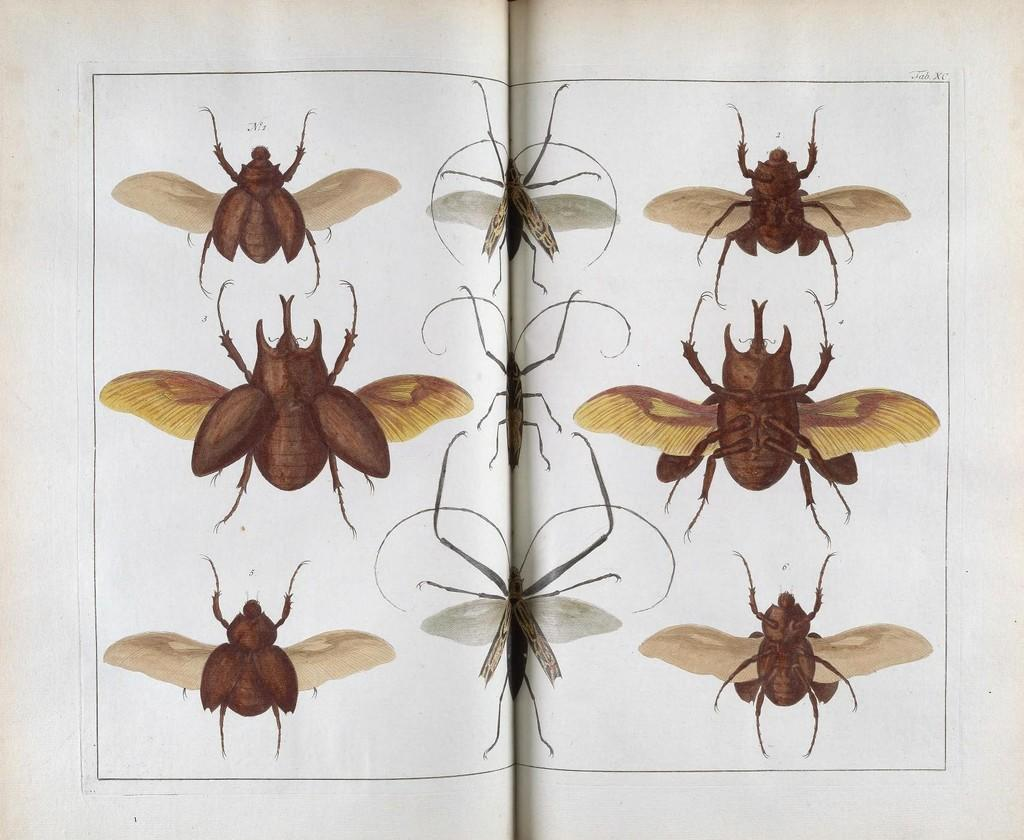What is the main object in the image? There is a book in the image. How is the book positioned in the image? The book is opened. What can be seen on the pages of the book? There are depictions of insects on the white papers in the book. How does the book sort the insects in the image? The book does not sort the insects in the image; it simply contains depictions of them on the white papers. 